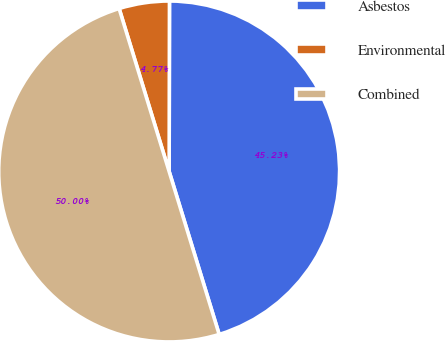Convert chart to OTSL. <chart><loc_0><loc_0><loc_500><loc_500><pie_chart><fcel>Asbestos<fcel>Environmental<fcel>Combined<nl><fcel>45.23%<fcel>4.77%<fcel>50.0%<nl></chart> 